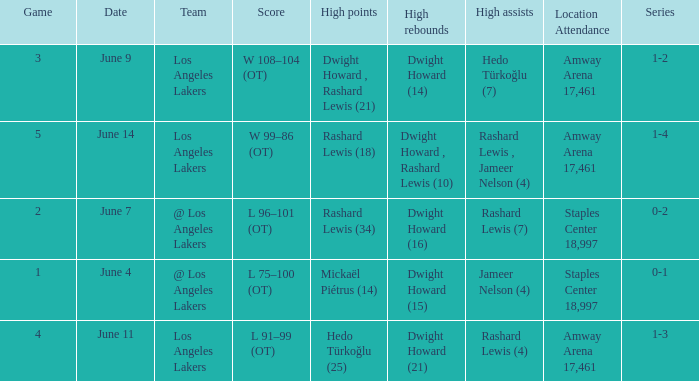What is Series, when Date is "June 7"? 0-2. 